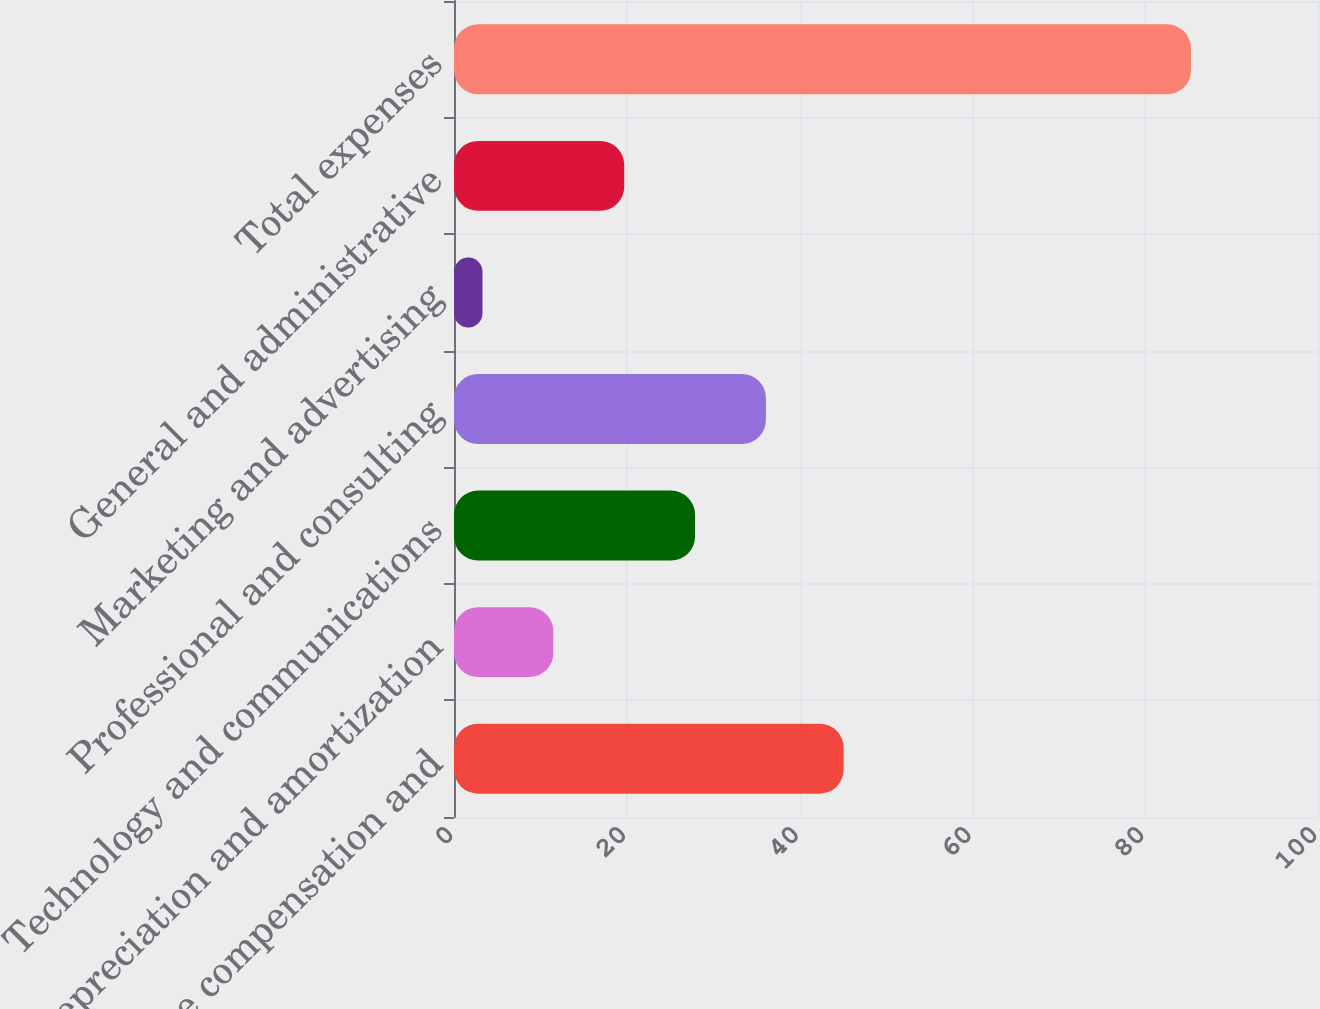<chart> <loc_0><loc_0><loc_500><loc_500><bar_chart><fcel>Employee compensation and<fcel>Depreciation and amortization<fcel>Technology and communications<fcel>Professional and consulting<fcel>Marketing and advertising<fcel>General and administrative<fcel>Total expenses<nl><fcel>45.1<fcel>11.5<fcel>27.9<fcel>36.1<fcel>3.3<fcel>19.7<fcel>85.3<nl></chart> 